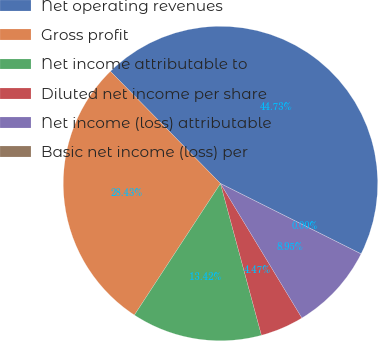<chart> <loc_0><loc_0><loc_500><loc_500><pie_chart><fcel>Net operating revenues<fcel>Gross profit<fcel>Net income attributable to<fcel>Diluted net income per share<fcel>Net income (loss) attributable<fcel>Basic net income (loss) per<nl><fcel>44.73%<fcel>28.43%<fcel>13.42%<fcel>4.47%<fcel>8.95%<fcel>0.0%<nl></chart> 